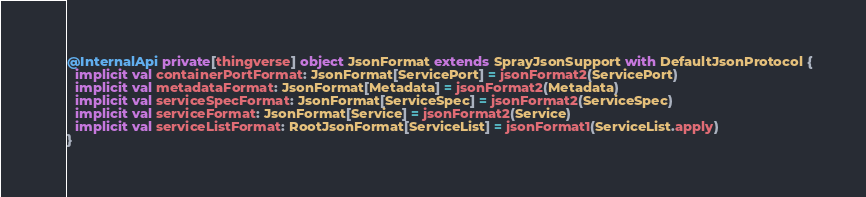Convert code to text. <code><loc_0><loc_0><loc_500><loc_500><_Scala_>@InternalApi private[thingverse] object JsonFormat extends SprayJsonSupport with DefaultJsonProtocol {
  implicit val containerPortFormat: JsonFormat[ServicePort] = jsonFormat2(ServicePort)
  implicit val metadataFormat: JsonFormat[Metadata] = jsonFormat2(Metadata)
  implicit val serviceSpecFormat: JsonFormat[ServiceSpec] = jsonFormat2(ServiceSpec)
  implicit val serviceFormat: JsonFormat[Service] = jsonFormat2(Service)
  implicit val serviceListFormat: RootJsonFormat[ServiceList] = jsonFormat1(ServiceList.apply)
}
</code> 